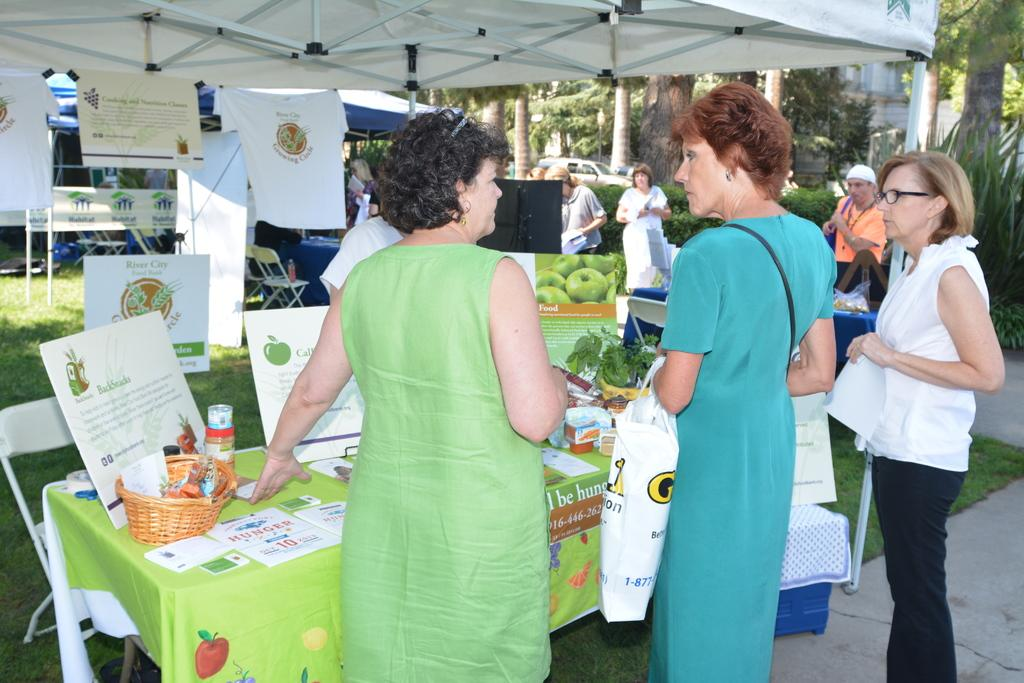Where are the people located in the image? The people are under the tents in the image. What can be found inside the tents? There are tables inside the tents. What is on the tables? Papers and other objects are present on the tables. What can be seen in the background of the image? There is a building visible in the background, and trees are present in the scene. What type of horn can be heard in the image? There is no horn present or audible in the image. What question are the people discussing under the tents? The image does not provide information about the specific question being discussed by the people under the tents. 